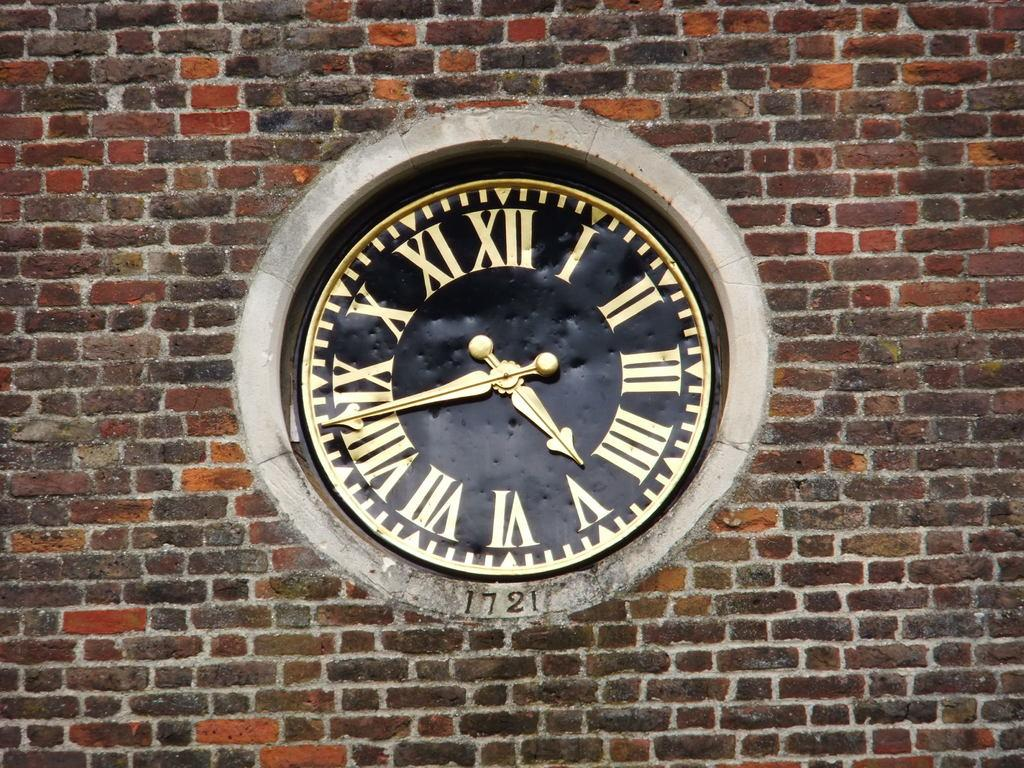<image>
Offer a succinct explanation of the picture presented. A clock embedded in a brick wall, made in 1721. 